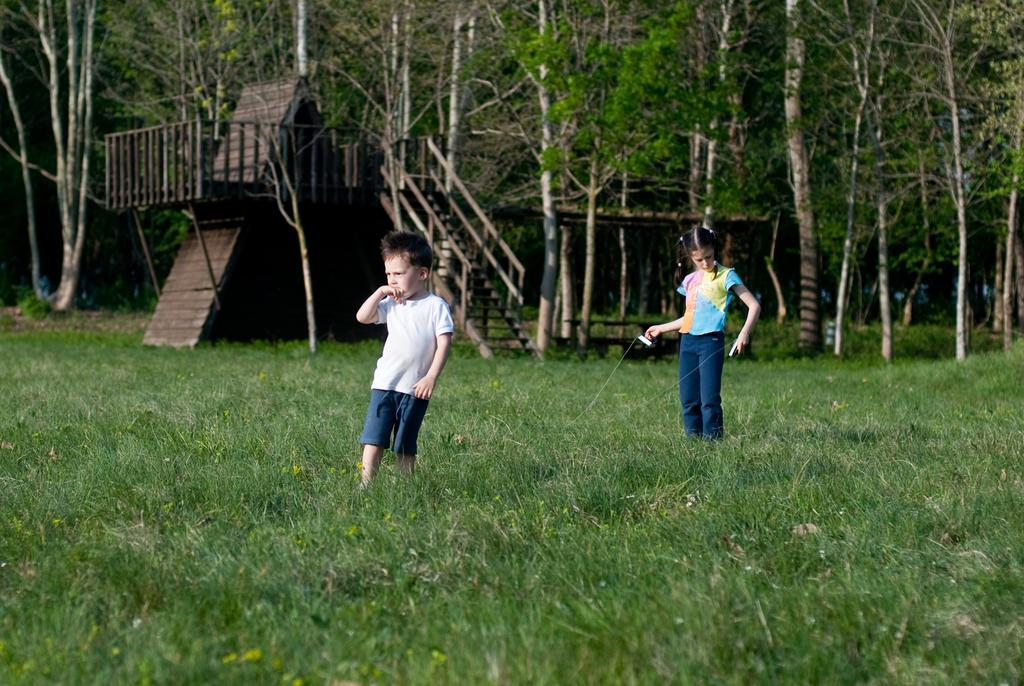How many people are in the image? There are two persons in the image. What can be seen in the background of the image? There are trees, wooden objects, and other objects in the background of the image. What type of vegetation is visible at the bottom of the image? There is grass at the bottom of the image. What type of cart is being used for the protest in the image? There is no cart or protest present in the image. Where is the mailbox located in the image? There is no mailbox present in the image. 